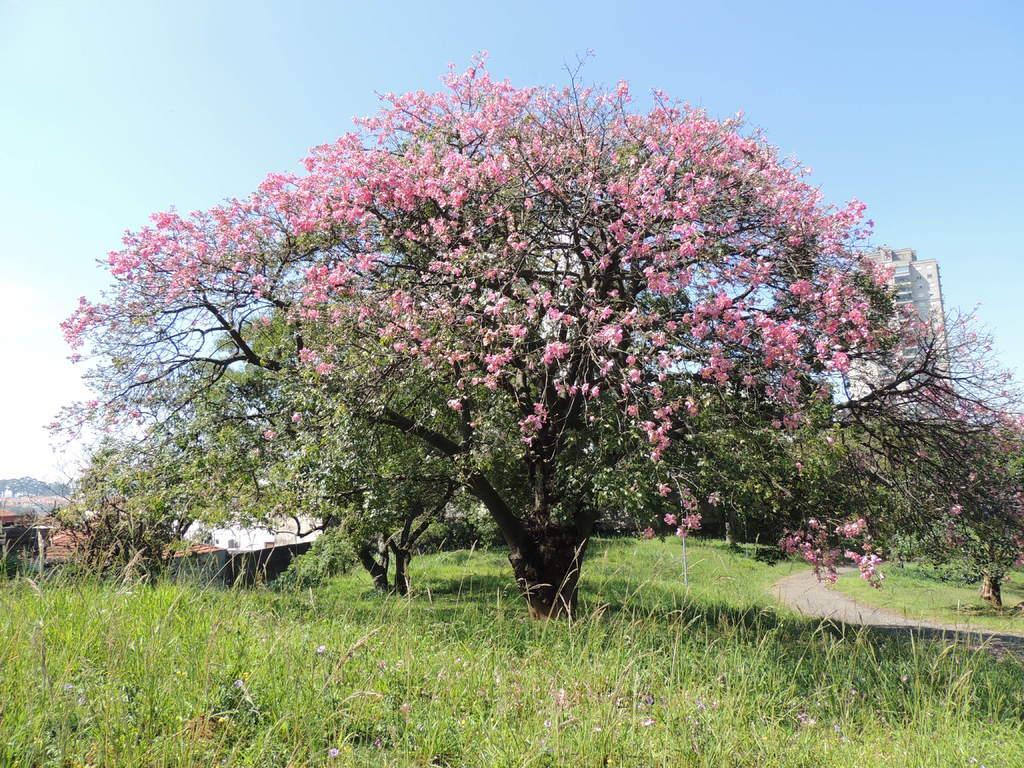Could you give a brief overview of what you see in this image? In this image we can see tree with flowers, buildings, road, plants and sky with clouds. 